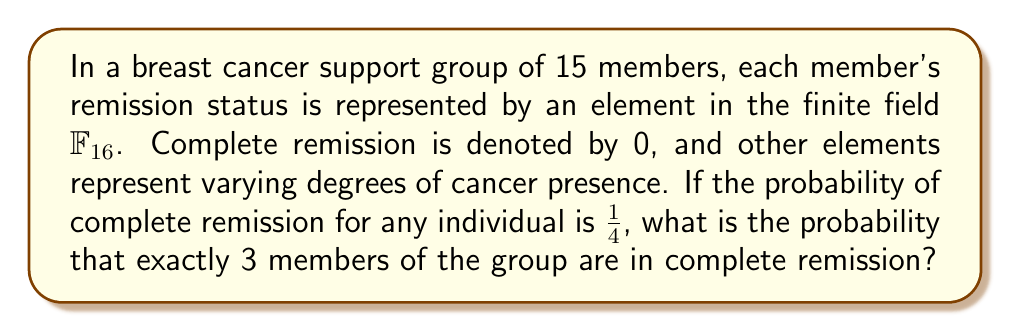Can you solve this math problem? Let's approach this step-by-step:

1) We are working with a finite field $\mathbb{F}_{16}$, which has 16 elements. One of these elements (0) represents complete remission.

2) The probability of complete remission for any individual is 1/4 = 0.25.

3) This scenario follows a binomial distribution, where:
   - n = 15 (total number of members)
   - k = 3 (number of successes, i.e., members in complete remission)
   - p = 1/4 = 0.25 (probability of success for each trial)

4) The probability of exactly k successes in n trials is given by the binomial probability formula:

   $$P(X = k) = \binom{n}{k} p^k (1-p)^{n-k}$$

5) Let's calculate each part:
   
   $$\binom{15}{3} = \frac{15!}{3!(15-3)!} = \frac{15!}{3!12!} = 455$$

   $$p^k = (0.25)^3 = 0.015625$$

   $$(1-p)^{n-k} = (0.75)^{12} \approx 0.0316$$

6) Now, let's put it all together:

   $$P(X = 3) = 455 \times 0.015625 \times 0.0316 \approx 0.2243$$

Therefore, the probability that exactly 3 members of the group are in complete remission is approximately 0.2243 or 22.43%.
Answer: 0.2243 